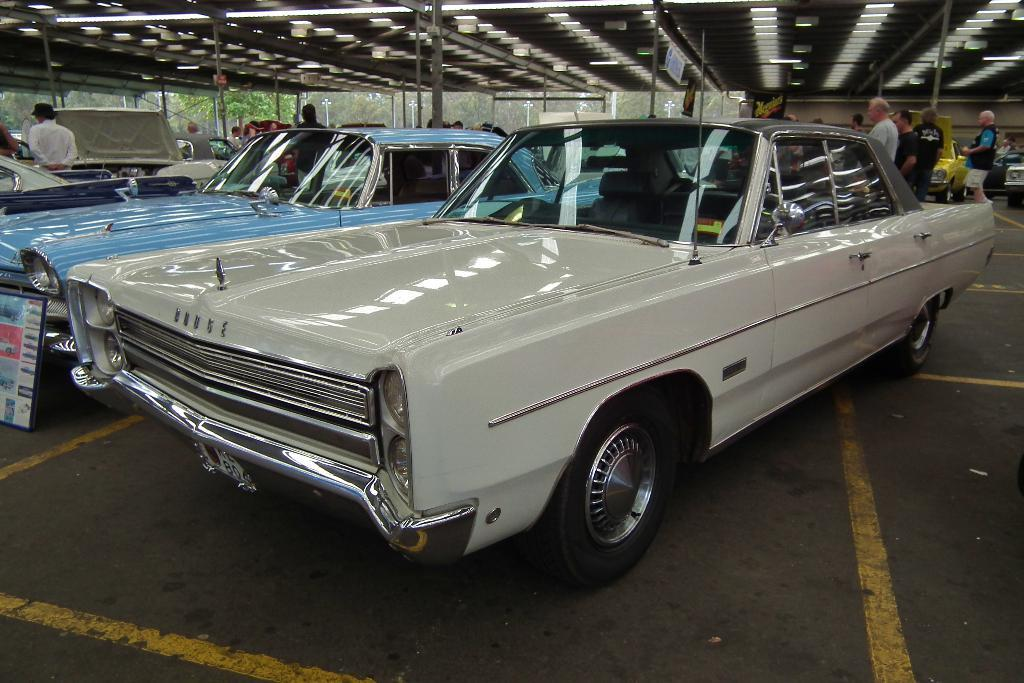What can be seen in the middle of the image? There are cars on the road in the center of the image. What else is visible in the image? There are people in the background of the image. What structure is partially visible at the top of the image? There is a roof visible at the top of the image. What type of ear is visible on the car in the image? There are no ears visible in the image, as it features cars on the road and people in the background. 